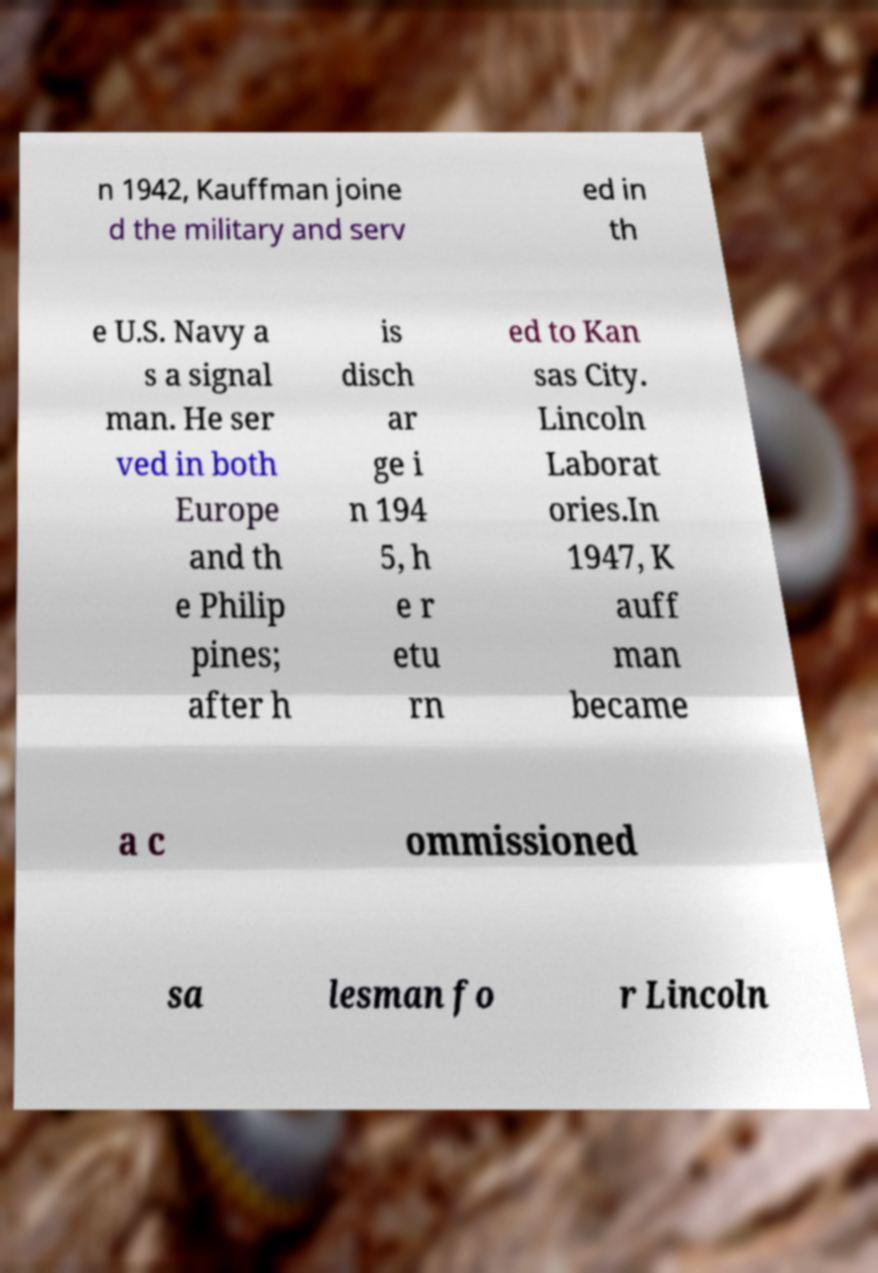Please identify and transcribe the text found in this image. n 1942, Kauffman joine d the military and serv ed in th e U.S. Navy a s a signal man. He ser ved in both Europe and th e Philip pines; after h is disch ar ge i n 194 5, h e r etu rn ed to Kan sas City. Lincoln Laborat ories.In 1947, K auff man became a c ommissioned sa lesman fo r Lincoln 